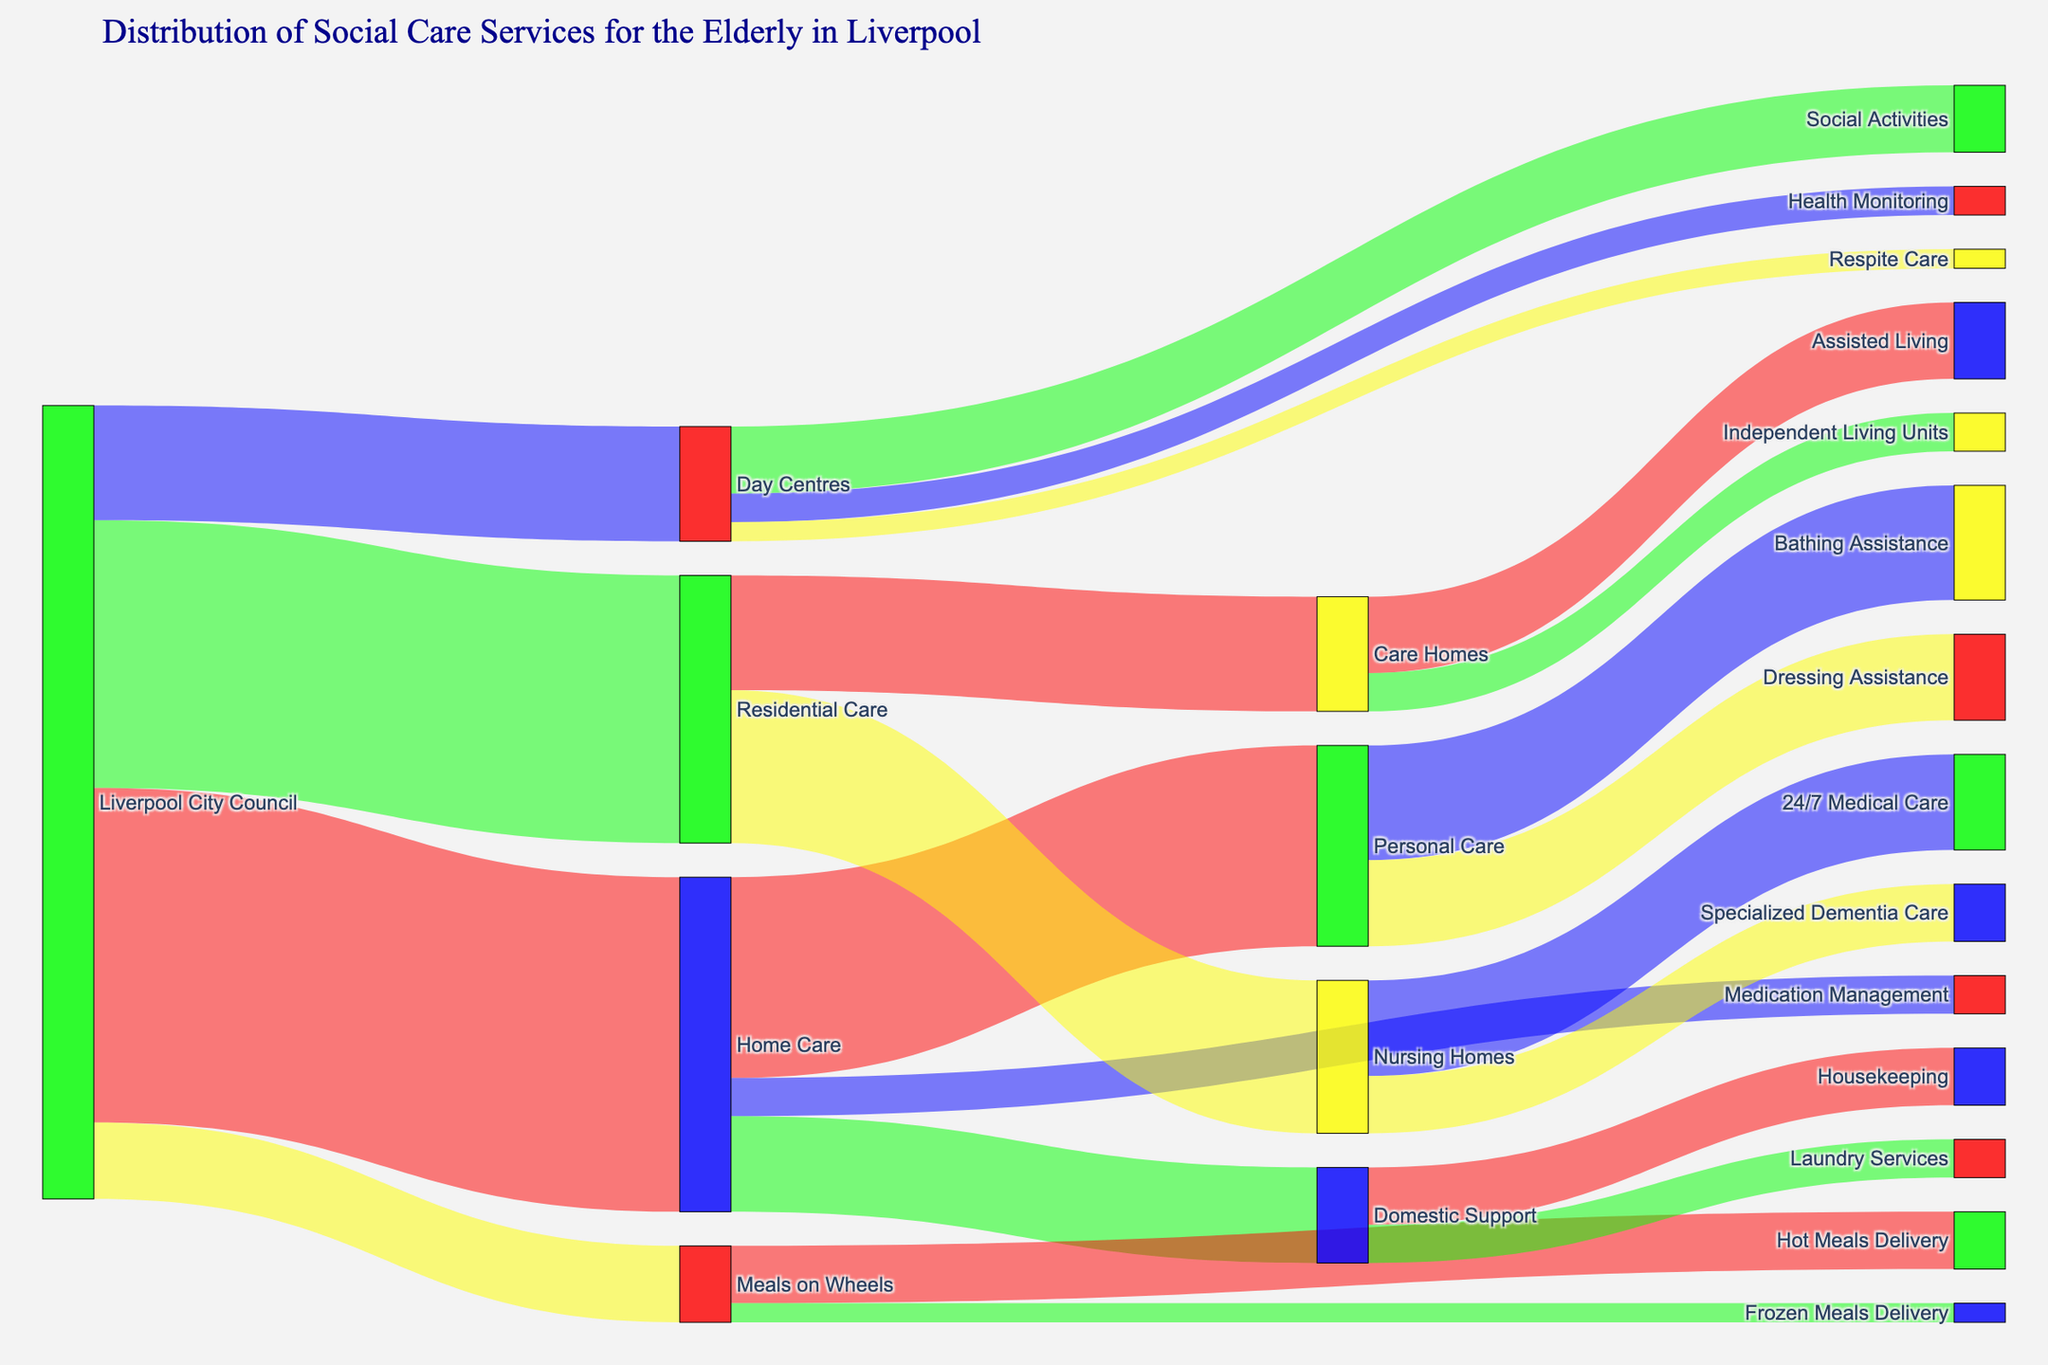How many services are provided under Home Care? In the Sankey Diagram, you can see three target service flows originating from Home Care: Personal Care, Domestic Support, and Medication Management. Counting these service flows gives the total number of services under Home Care.
Answer: 3 From Liverpool City Council, which service has the smallest allocation? By looking at the diagram, you can see the flows and their respective values. Among Home Care, Residential Care, Day Centres, and Meals on Wheels, Meals on Wheels has the smallest value with 800.
Answer: Meals on Wheels What is the total number of services provided under Day Centres? The diagram shows three service flows under Day Centres: Social Activities, Health Monitoring, and Respite Care. Adding these values (700 + 300 + 200) gives the total number of services provided under Day Centres.
Answer: 3 What is the combined value of services provided by Care Homes? Care Homes has two services: Assisted Living and Independent Living Units. You sum their values (800 + 400) to get the combined value.
Answer: 1200 Which has a higher value, Personal Care from Home Care or Nursing Homes from Residential Care? Looking at the flows, Personal Care has a value of 2100 from Home Care, and Nursing Homes has a value of 1600 from Residential Care. Comparing these values, Personal Care is higher.
Answer: Personal Care What service receives the highest value from Liverpool City Council? The diagram shows the values of Home Care, Residential Care, Day Centres, and Meals on Wheels. Home Care has the highest value of 3500.
Answer: Home Care How many total services are provided by Liverpool City Council? The diagram shows four flows originating from Liverpool City Council: Home Care, Residential Care, Day Centres, and Meals on Wheels. Adding these values (3500 + 2800 + 1200 + 800) gives the total number of services provided.
Answer: 4 Is the value of Day Centres less than half of the value of Residential Care? The value of Day Centres is 1200, and the value of Residential Care is 2800. Half of Residential Care's value is 1400. Since 1200 < 1400, Day Centres' value is less than half of Residential Care.
Answer: Yes Which two services receive equal value from Liverpool City Council? Observing the flows from Liverpool City Council, the values of various services are 3500, 2800, 1200, and 800. Only Home Care (3500) and Residential Care (2800) have unique values while Day Centres and Meals on Wheels each have unique values themselves. No two services have the exact same value.
Answer: None 